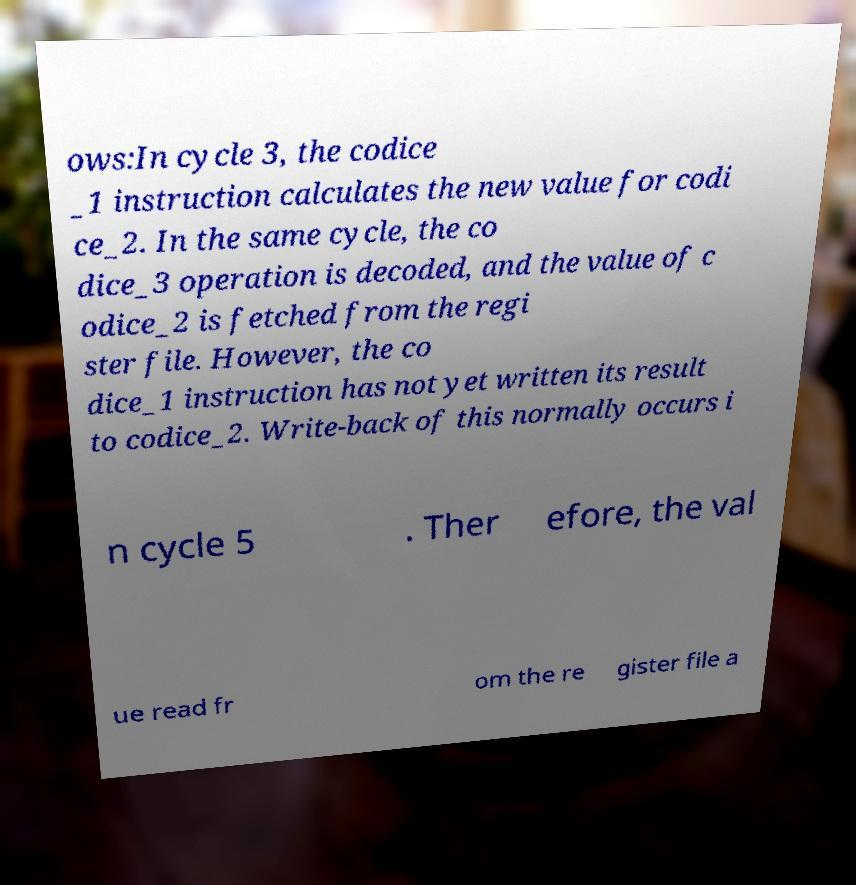Could you assist in decoding the text presented in this image and type it out clearly? ows:In cycle 3, the codice _1 instruction calculates the new value for codi ce_2. In the same cycle, the co dice_3 operation is decoded, and the value of c odice_2 is fetched from the regi ster file. However, the co dice_1 instruction has not yet written its result to codice_2. Write-back of this normally occurs i n cycle 5 . Ther efore, the val ue read fr om the re gister file a 